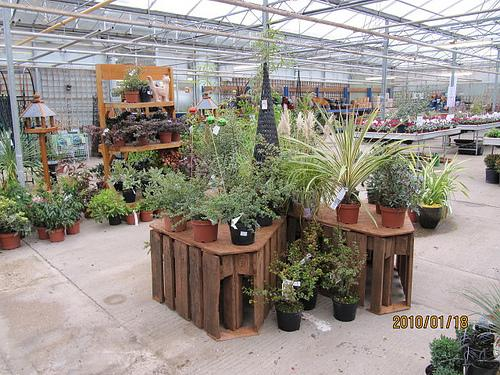What can be found here? Please explain your reasoning. pots. There are a lot of plants that are in different types of containers. 